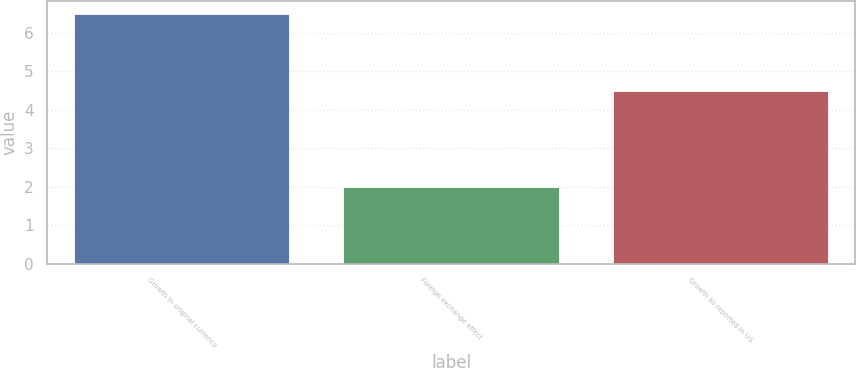Convert chart. <chart><loc_0><loc_0><loc_500><loc_500><bar_chart><fcel>Growth in original currency<fcel>Foreign exchange effect<fcel>Growth as reported in US<nl><fcel>6.5<fcel>2<fcel>4.5<nl></chart> 